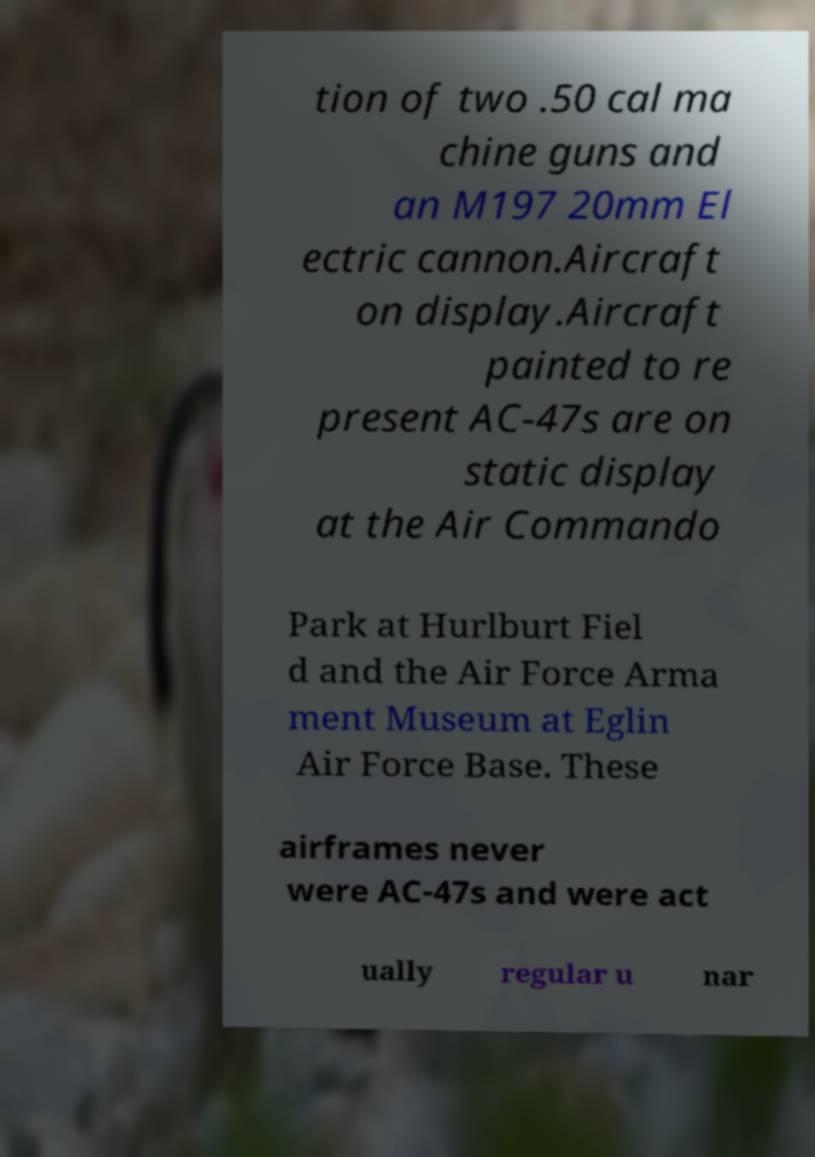There's text embedded in this image that I need extracted. Can you transcribe it verbatim? tion of two .50 cal ma chine guns and an M197 20mm El ectric cannon.Aircraft on display.Aircraft painted to re present AC-47s are on static display at the Air Commando Park at Hurlburt Fiel d and the Air Force Arma ment Museum at Eglin Air Force Base. These airframes never were AC-47s and were act ually regular u nar 